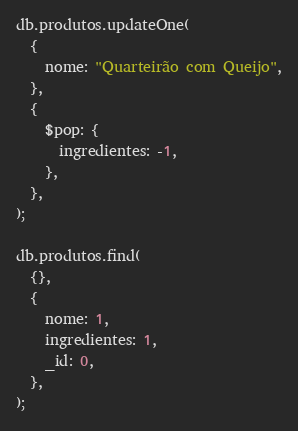<code> <loc_0><loc_0><loc_500><loc_500><_JavaScript_>db.produtos.updateOne(
  {
    nome: "Quarteirão com Queijo",
  },
  {
    $pop: {
      ingredientes: -1,
    },
  },
);

db.produtos.find(
  {},
  {
    nome: 1,
    ingredientes: 1,
    _id: 0,
  },
);</code> 